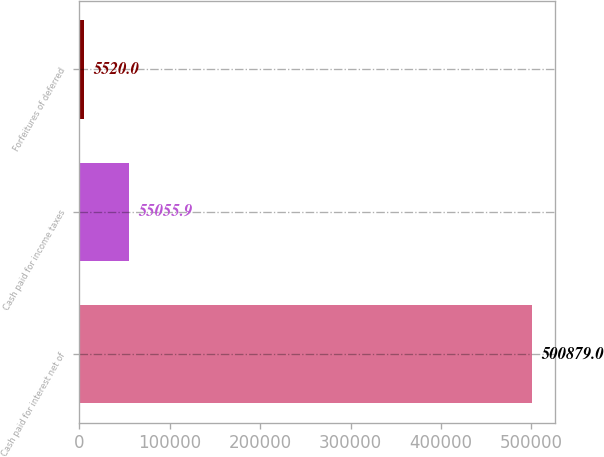Convert chart to OTSL. <chart><loc_0><loc_0><loc_500><loc_500><bar_chart><fcel>Cash paid for interest net of<fcel>Cash paid for income taxes<fcel>Forfeitures of deferred<nl><fcel>500879<fcel>55055.9<fcel>5520<nl></chart> 